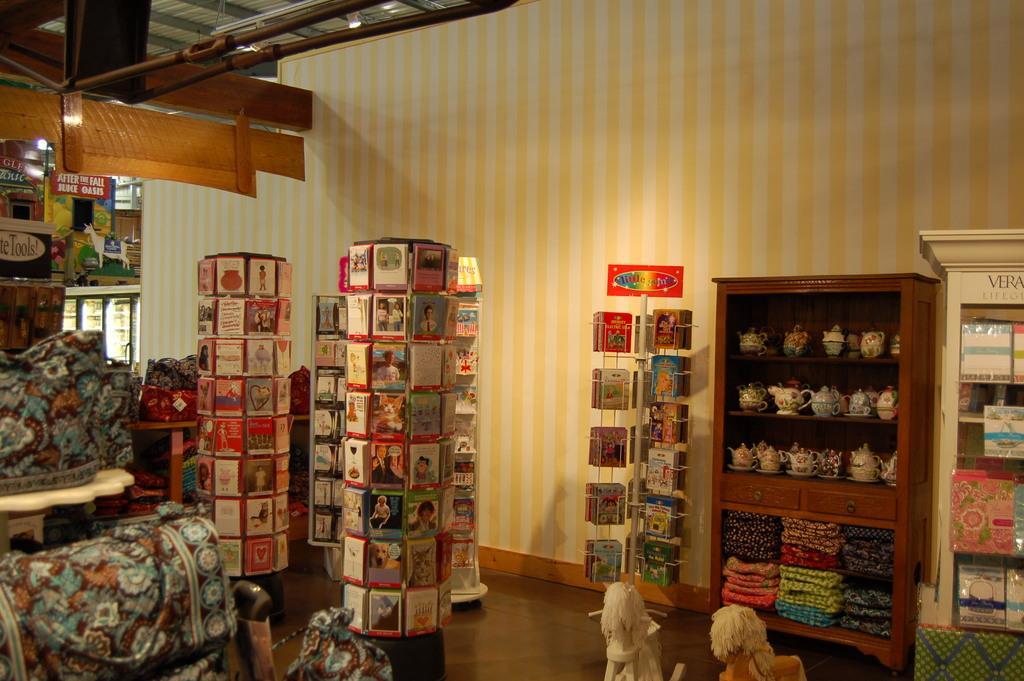Describe this image in one or two sentences. In the image in the center we can see racks,book stands,tables,books,pots,blankets,toys,boxes,banners,sofa,cloth,sign board and few other objects. In the background there is a wall,roof and light. 